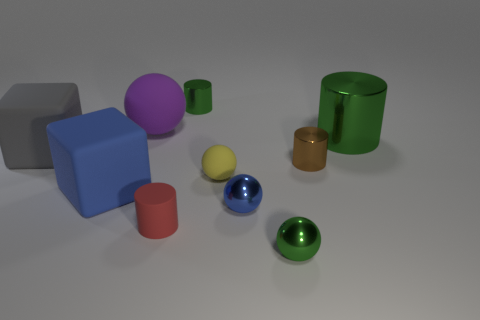Subtract all cylinders. How many objects are left? 6 Subtract all small blue metallic balls. Subtract all large blue blocks. How many objects are left? 8 Add 6 small brown shiny cylinders. How many small brown shiny cylinders are left? 7 Add 4 big blue rubber blocks. How many big blue rubber blocks exist? 5 Subtract 1 brown cylinders. How many objects are left? 9 